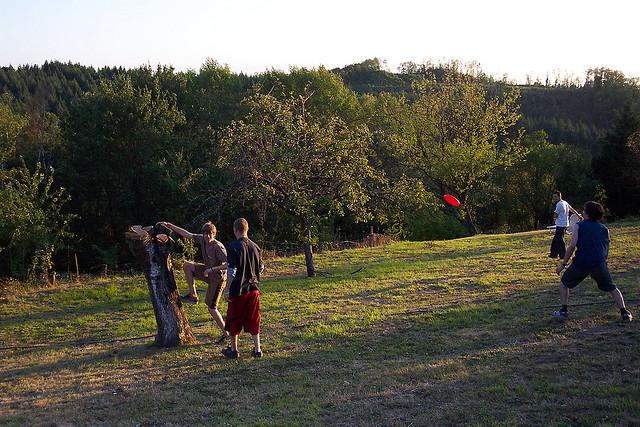Is this a small suburban park?
Concise answer only. Yes. What is the woman trying to catch?
Quick response, please. Frisbee. Is this photo taken at night?
Concise answer only. No. Are they going up hill or down?
Write a very short answer. Down. What is the first boy carrying?
Keep it brief. Frisbee. What color is the Frisbee the guy is trying to grab?
Keep it brief. Red. What color is the frisbee?
Answer briefly. Red. 